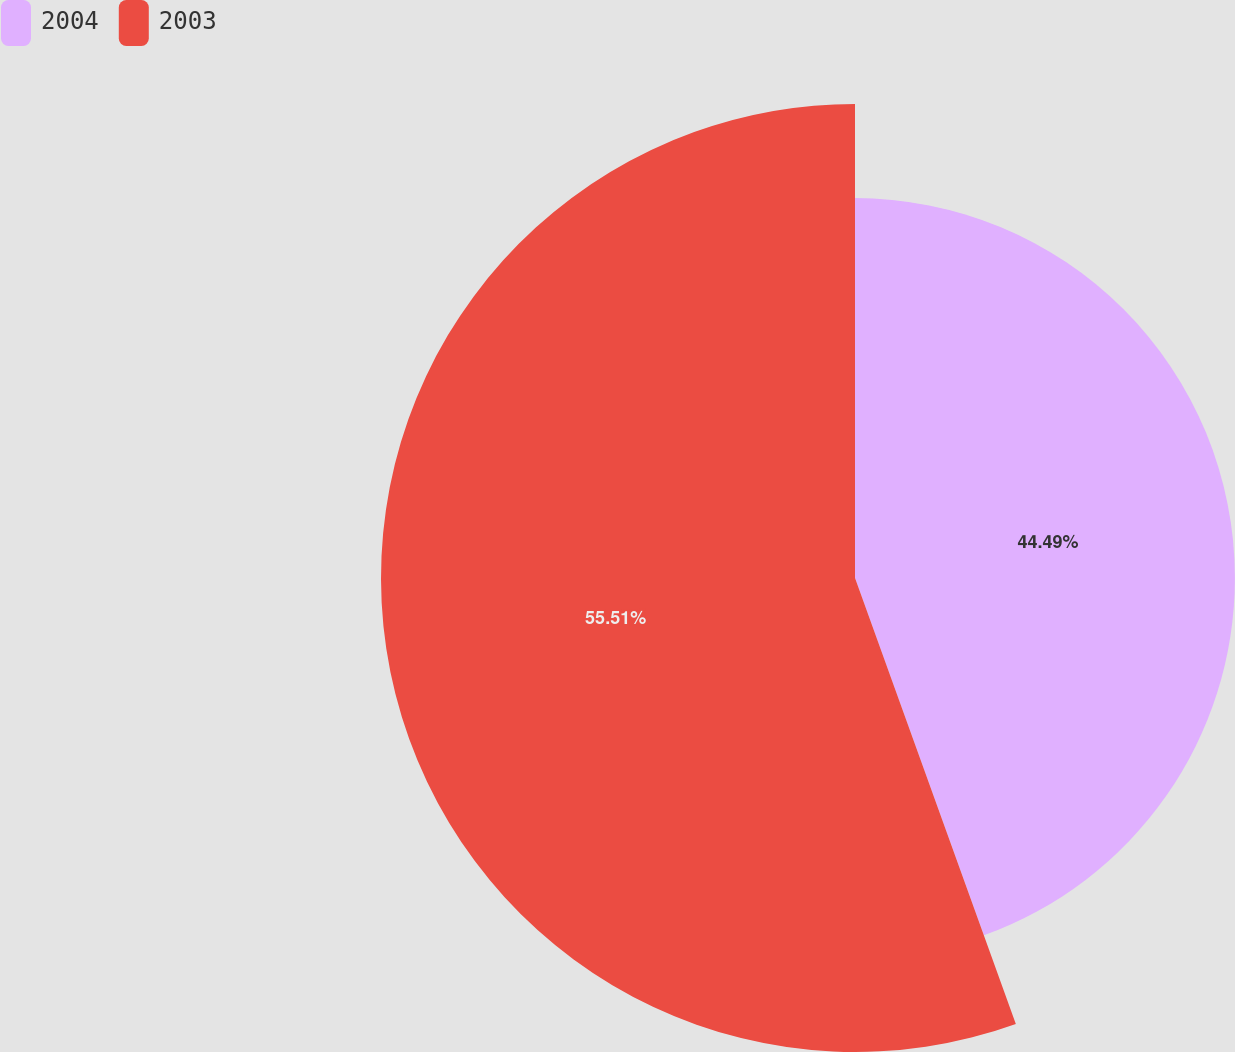Convert chart. <chart><loc_0><loc_0><loc_500><loc_500><pie_chart><fcel>2004<fcel>2003<nl><fcel>44.49%<fcel>55.51%<nl></chart> 